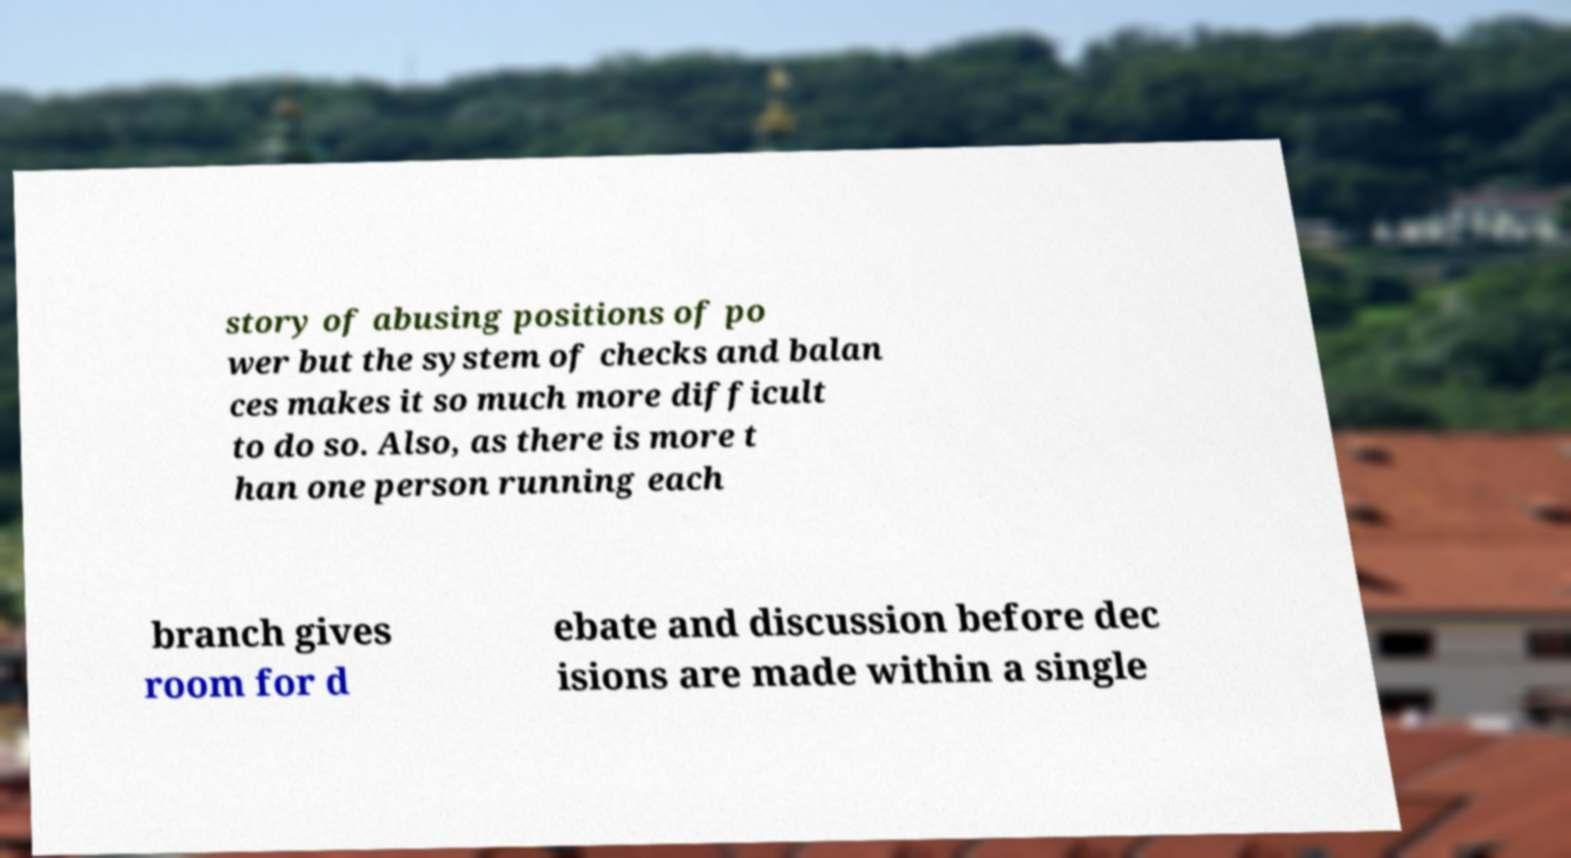Please read and relay the text visible in this image. What does it say? story of abusing positions of po wer but the system of checks and balan ces makes it so much more difficult to do so. Also, as there is more t han one person running each branch gives room for d ebate and discussion before dec isions are made within a single 